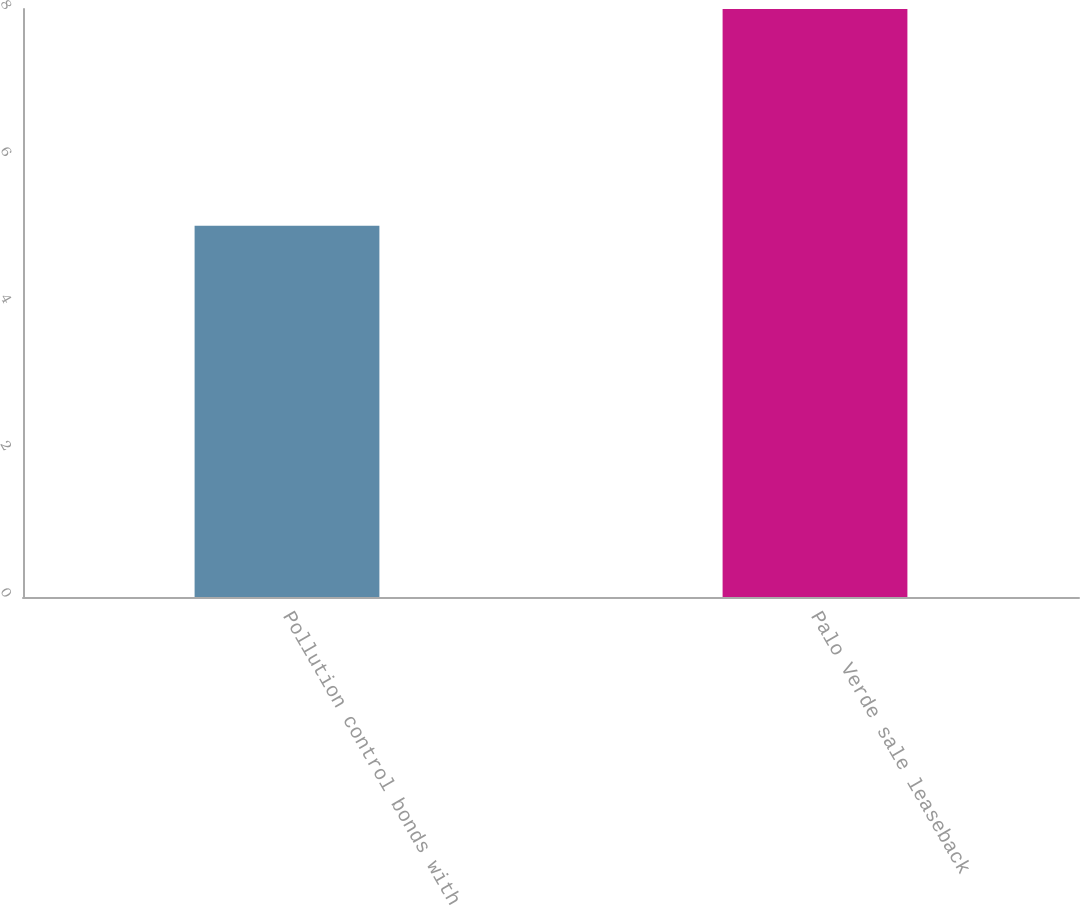Convert chart. <chart><loc_0><loc_0><loc_500><loc_500><bar_chart><fcel>Pollution control bonds with<fcel>Palo Verde sale leaseback<nl><fcel>5.05<fcel>8<nl></chart> 